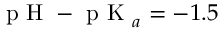Convert formula to latex. <formula><loc_0><loc_0><loc_500><loc_500>p H - p K _ { a } = - 1 . 5</formula> 